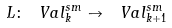<formula> <loc_0><loc_0><loc_500><loc_500>L \colon \ V a l ^ { s m } _ { k } \to \ V a l ^ { s m } _ { k + 1 }</formula> 